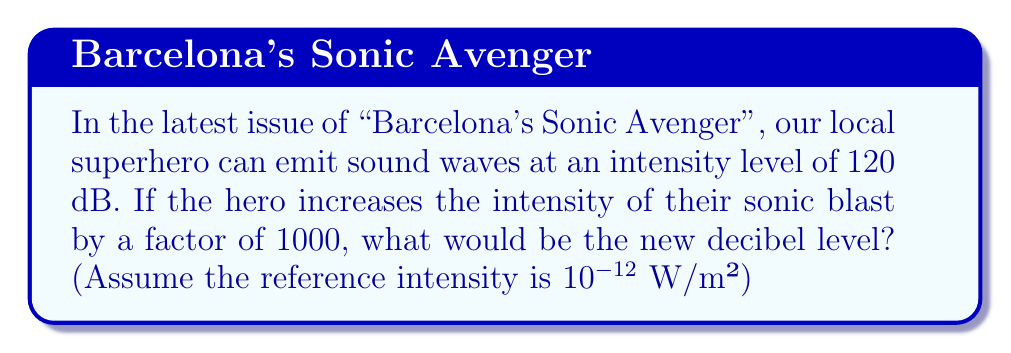Teach me how to tackle this problem. Let's approach this step-by-step:

1) The decibel (dB) scale is logarithmic and is defined by the equation:

   $$ L = 10 \log_{10}\left(\frac{I}{I_0}\right) $$

   Where $L$ is the sound level in dB, $I$ is the intensity, and $I_0$ is the reference intensity.

2) We're given that the initial sound level is 120 dB. Let's call the initial intensity $I_1$. We can write:

   $$ 120 = 10 \log_{10}\left(\frac{I_1}{10^{-12}}\right) $$

3) The new intensity $I_2$ is 1000 times $I_1$. So $I_2 = 1000I_1$.

4) We want to find the new sound level $L_2$:

   $$ L_2 = 10 \log_{10}\left(\frac{I_2}{10^{-12}}\right) = 10 \log_{10}\left(\frac{1000I_1}{10^{-12}}\right) $$

5) We can rewrite this as:

   $$ L_2 = 10 \log_{10}\left(1000 \cdot \frac{I_1}{10^{-12}}\right) = 10 \log_{10}(1000) + 10 \log_{10}\left(\frac{I_1}{10^{-12}}\right) $$

6) We recognize the second term as the original 120 dB:

   $$ L_2 = 10 \log_{10}(1000) + 120 $$

7) Calculate:
   $$ L_2 = 10 \cdot 3 + 120 = 30 + 120 = 150 $$

Thus, the new sound level is 150 dB.
Answer: 150 dB 